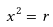<formula> <loc_0><loc_0><loc_500><loc_500>x ^ { 2 } = r</formula> 